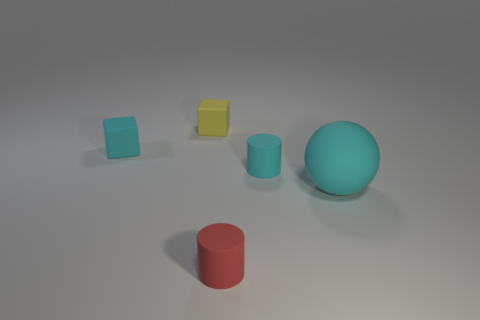What material is the cyan object that is on the right side of the tiny yellow matte cube and to the left of the cyan ball?
Your response must be concise. Rubber. What number of objects are either small objects that are in front of the yellow object or brown shiny cubes?
Make the answer very short. 3. Is there a yellow metallic object that has the same size as the matte ball?
Your answer should be compact. No. How many small cylinders are in front of the large cyan rubber sphere and behind the small red matte thing?
Your response must be concise. 0. There is a big cyan rubber thing; how many yellow rubber cubes are left of it?
Provide a succinct answer. 1. Is there a tiny cyan thing that has the same shape as the small yellow thing?
Provide a short and direct response. Yes. Does the tiny red object have the same shape as the tiny cyan thing that is to the right of the tiny yellow matte object?
Your response must be concise. Yes. How many cubes are tiny red things or yellow matte objects?
Make the answer very short. 1. There is a tiny matte thing in front of the large cyan matte ball; what shape is it?
Ensure brevity in your answer.  Cylinder. What number of cyan blocks have the same material as the sphere?
Keep it short and to the point. 1. 